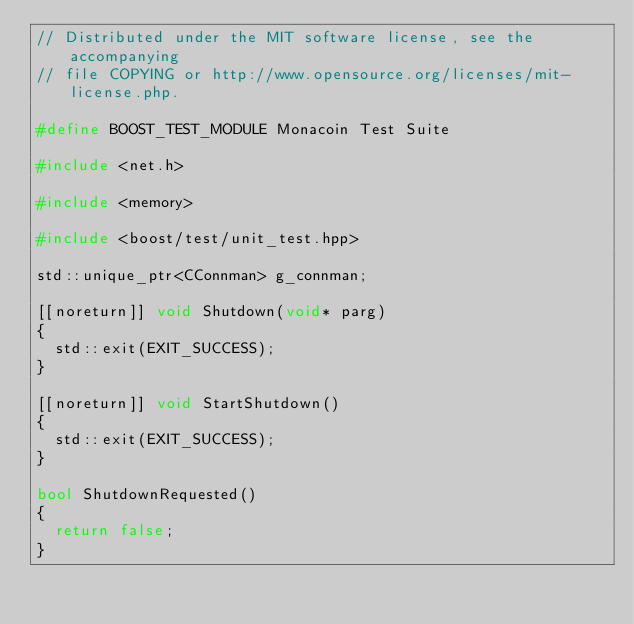<code> <loc_0><loc_0><loc_500><loc_500><_C++_>// Distributed under the MIT software license, see the accompanying
// file COPYING or http://www.opensource.org/licenses/mit-license.php.

#define BOOST_TEST_MODULE Monacoin Test Suite

#include <net.h>

#include <memory>

#include <boost/test/unit_test.hpp>

std::unique_ptr<CConnman> g_connman;

[[noreturn]] void Shutdown(void* parg)
{
  std::exit(EXIT_SUCCESS);
}

[[noreturn]] void StartShutdown()
{
  std::exit(EXIT_SUCCESS);
}

bool ShutdownRequested()
{
  return false;
}
</code> 